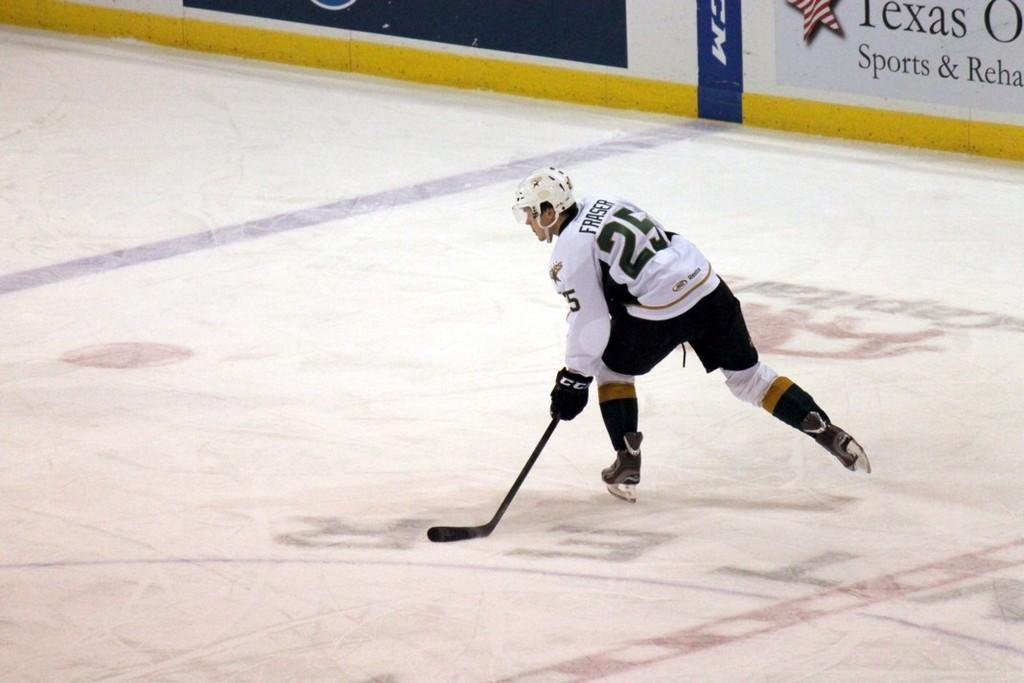What is the main subject of the image? There is a person in the image. What is the person wearing? The person is wearing clothes. What activity is the person engaged in? The person is playing ice hockey. What object is the person holding in their hand? The person is holding a stick. What type of food is the person cooking in the image? There is no indication in the image that the person is cooking or preparing any food. 